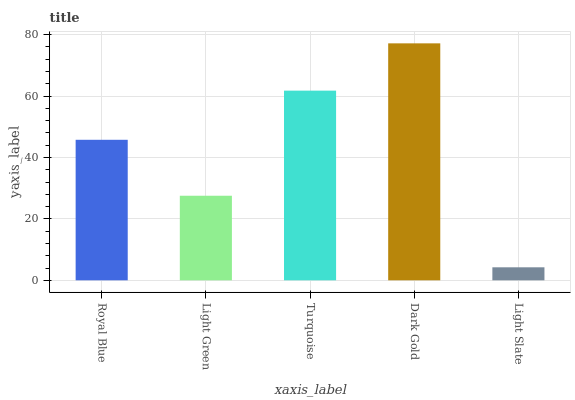Is Light Slate the minimum?
Answer yes or no. Yes. Is Dark Gold the maximum?
Answer yes or no. Yes. Is Light Green the minimum?
Answer yes or no. No. Is Light Green the maximum?
Answer yes or no. No. Is Royal Blue greater than Light Green?
Answer yes or no. Yes. Is Light Green less than Royal Blue?
Answer yes or no. Yes. Is Light Green greater than Royal Blue?
Answer yes or no. No. Is Royal Blue less than Light Green?
Answer yes or no. No. Is Royal Blue the high median?
Answer yes or no. Yes. Is Royal Blue the low median?
Answer yes or no. Yes. Is Turquoise the high median?
Answer yes or no. No. Is Turquoise the low median?
Answer yes or no. No. 